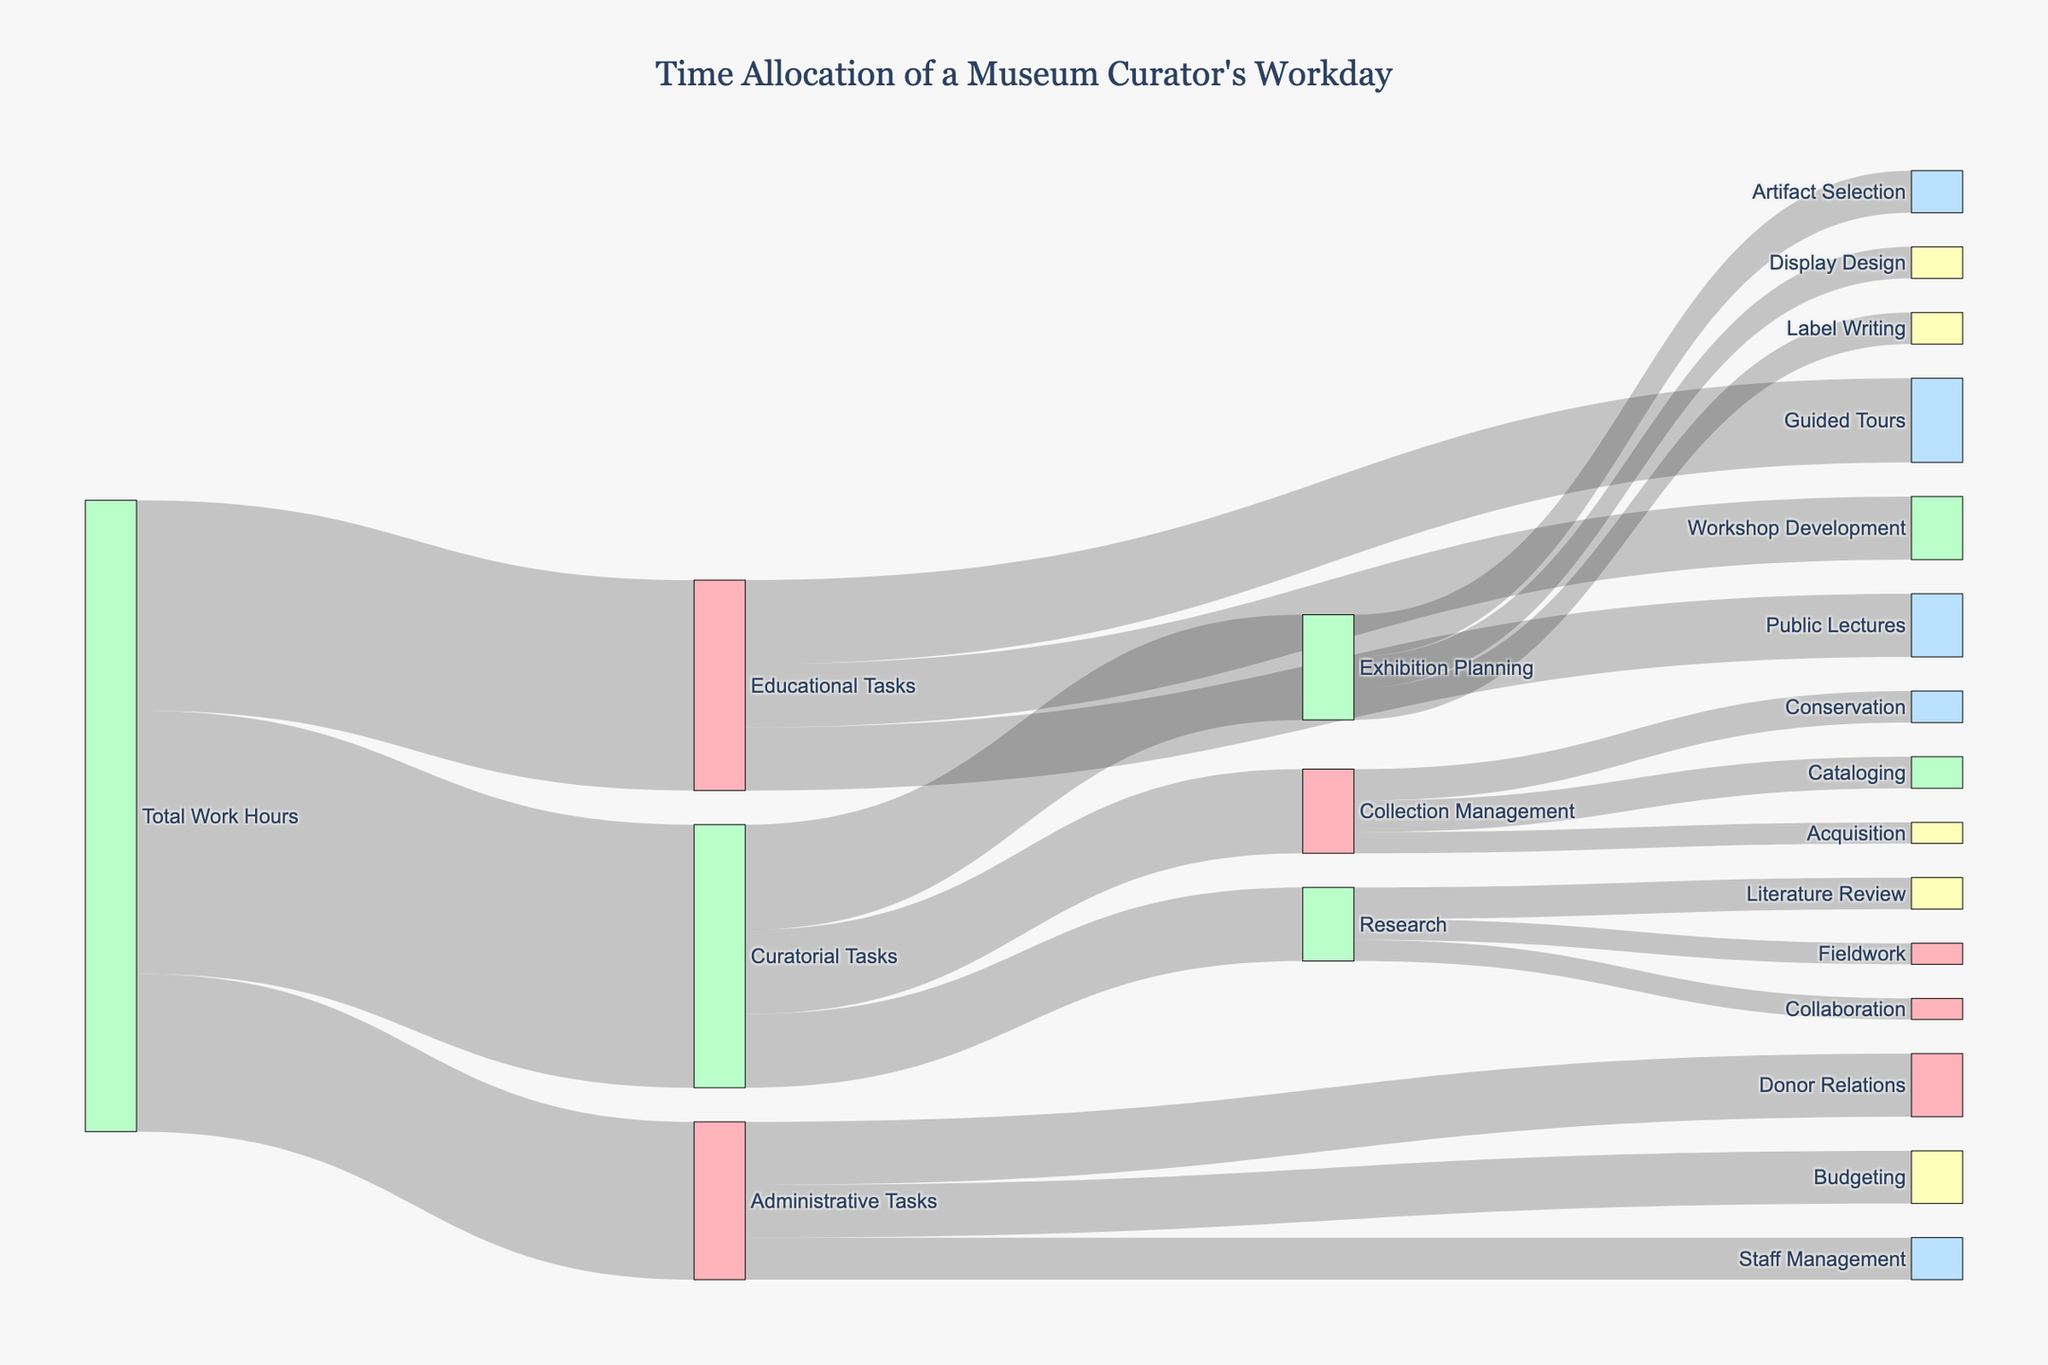what is the title of the Sankey diagram? The title of the Sankey diagram is located at the top of the figure, providing a brief description of what the diagram represents.
Answer: Time Allocation of a Museum Curator's Workday What is the total amount of work hours allocated to curatorial tasks? To find the work hours allocated to curatorial tasks, look at the flow from "Total Work Hours" to "Curatorial Tasks".
Answer: 25 Which task under "Educational Tasks" has the highest allocation of hours? Look at the branching from "Educational Tasks" and identify which task has the largest value.
Answer: Guided Tours How many hours are spent on Exhibition Planning compared to Collection Management? Check the values of "Exhibition Planning" and "Collection Management" under "Curatorial Tasks", and compare them.
Answer: Exhibition Planning: 10, Collection Management: 8 What is the combined total of hours spent on Research and Budgeting? Sum the values associated with "Research" under "Curatorial Tasks" and "Budgeting" under "Administrative Tasks". Research has 7 hours and Budgeting has 5 hours. The total is 7 + 5 = 12.
Answer: 12 How much time is dedicated to Artifact Selection within the Exhibition Planning task? Follow the flow from "Exhibition Planning" to its sub-tasks and locate the hours dedicated to "Artifact Selection".
Answer: 4 Which task within "Administrative Tasks" has the least allocation of hours? Look at the branching from "Administrative Tasks" and find the task with the smallest value.
Answer: Staff Management Is more time allocated to Public Lectures or Collaboration? Check the values associated with "Public Lectures" under "Educational Tasks" and "Collaboration" under "Research". Public Lectures has 6 hours and Collaboration has 2 hours.
Answer: Public Lectures What is the percentage of time allocated to each task under "Curatorial Tasks"? Calculate the percentage of time by dividing each task's hours by the total curatorial hours (25) and multiplying by 100: 
Exhibition Planning: (10/25) * 100 = 40%, 
Collection Management: (8/25) * 100 = 32%, 
Research: (7/25) * 100 = 28%.
Answer: Exhibition Planning: 40%, Collection Management: 32%, Research: 28% How does the time spent on administrative tasks compare to educational tasks? Compare the total hours for "Administrative Tasks" and "Educational Tasks". Administrative Tasks has 15 hours and Educational Tasks has 20 hours.
Answer: Educational Tasks > Administrative Tasks 